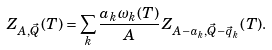<formula> <loc_0><loc_0><loc_500><loc_500>Z _ { A , \vec { Q } } ( T ) = \sum _ { k } \frac { a _ { k } \omega _ { k } ( T ) } { A } Z _ { A - a _ { k } , \vec { Q } - \vec { q } _ { k } } ( T ) .</formula> 